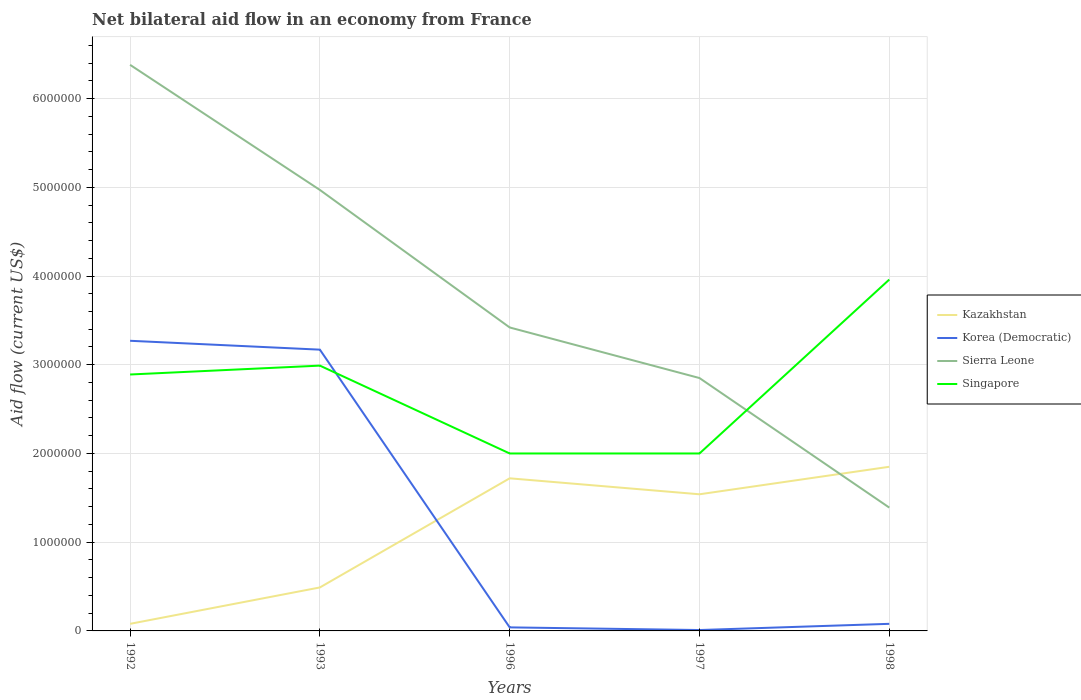Does the line corresponding to Sierra Leone intersect with the line corresponding to Korea (Democratic)?
Ensure brevity in your answer.  No. Is the number of lines equal to the number of legend labels?
Make the answer very short. Yes. In which year was the net bilateral aid flow in Korea (Democratic) maximum?
Your response must be concise. 1997. What is the total net bilateral aid flow in Sierra Leone in the graph?
Provide a short and direct response. 1.55e+06. What is the difference between the highest and the second highest net bilateral aid flow in Korea (Democratic)?
Make the answer very short. 3.26e+06. Is the net bilateral aid flow in Kazakhstan strictly greater than the net bilateral aid flow in Singapore over the years?
Make the answer very short. Yes. What is the difference between two consecutive major ticks on the Y-axis?
Provide a succinct answer. 1.00e+06. Are the values on the major ticks of Y-axis written in scientific E-notation?
Give a very brief answer. No. Does the graph contain grids?
Make the answer very short. Yes. How many legend labels are there?
Offer a very short reply. 4. What is the title of the graph?
Offer a terse response. Net bilateral aid flow in an economy from France. What is the label or title of the X-axis?
Your response must be concise. Years. What is the label or title of the Y-axis?
Your response must be concise. Aid flow (current US$). What is the Aid flow (current US$) of Korea (Democratic) in 1992?
Your answer should be very brief. 3.27e+06. What is the Aid flow (current US$) of Sierra Leone in 1992?
Provide a succinct answer. 6.38e+06. What is the Aid flow (current US$) in Singapore in 1992?
Your answer should be very brief. 2.89e+06. What is the Aid flow (current US$) in Korea (Democratic) in 1993?
Provide a short and direct response. 3.17e+06. What is the Aid flow (current US$) of Sierra Leone in 1993?
Provide a succinct answer. 4.97e+06. What is the Aid flow (current US$) in Singapore in 1993?
Your answer should be very brief. 2.99e+06. What is the Aid flow (current US$) of Kazakhstan in 1996?
Keep it short and to the point. 1.72e+06. What is the Aid flow (current US$) in Sierra Leone in 1996?
Keep it short and to the point. 3.42e+06. What is the Aid flow (current US$) of Singapore in 1996?
Ensure brevity in your answer.  2.00e+06. What is the Aid flow (current US$) of Kazakhstan in 1997?
Your answer should be compact. 1.54e+06. What is the Aid flow (current US$) in Korea (Democratic) in 1997?
Your answer should be compact. 10000. What is the Aid flow (current US$) of Sierra Leone in 1997?
Your response must be concise. 2.85e+06. What is the Aid flow (current US$) in Singapore in 1997?
Offer a very short reply. 2.00e+06. What is the Aid flow (current US$) in Kazakhstan in 1998?
Your response must be concise. 1.85e+06. What is the Aid flow (current US$) in Korea (Democratic) in 1998?
Your answer should be very brief. 8.00e+04. What is the Aid flow (current US$) of Sierra Leone in 1998?
Your answer should be very brief. 1.39e+06. What is the Aid flow (current US$) of Singapore in 1998?
Ensure brevity in your answer.  3.96e+06. Across all years, what is the maximum Aid flow (current US$) in Kazakhstan?
Provide a short and direct response. 1.85e+06. Across all years, what is the maximum Aid flow (current US$) of Korea (Democratic)?
Your answer should be compact. 3.27e+06. Across all years, what is the maximum Aid flow (current US$) of Sierra Leone?
Your answer should be compact. 6.38e+06. Across all years, what is the maximum Aid flow (current US$) of Singapore?
Keep it short and to the point. 3.96e+06. Across all years, what is the minimum Aid flow (current US$) of Sierra Leone?
Provide a succinct answer. 1.39e+06. What is the total Aid flow (current US$) of Kazakhstan in the graph?
Your answer should be very brief. 5.68e+06. What is the total Aid flow (current US$) of Korea (Democratic) in the graph?
Ensure brevity in your answer.  6.57e+06. What is the total Aid flow (current US$) of Sierra Leone in the graph?
Offer a terse response. 1.90e+07. What is the total Aid flow (current US$) of Singapore in the graph?
Offer a very short reply. 1.38e+07. What is the difference between the Aid flow (current US$) in Kazakhstan in 1992 and that in 1993?
Keep it short and to the point. -4.10e+05. What is the difference between the Aid flow (current US$) of Sierra Leone in 1992 and that in 1993?
Your response must be concise. 1.41e+06. What is the difference between the Aid flow (current US$) in Kazakhstan in 1992 and that in 1996?
Your response must be concise. -1.64e+06. What is the difference between the Aid flow (current US$) of Korea (Democratic) in 1992 and that in 1996?
Offer a terse response. 3.23e+06. What is the difference between the Aid flow (current US$) in Sierra Leone in 1992 and that in 1996?
Your answer should be compact. 2.96e+06. What is the difference between the Aid flow (current US$) in Singapore in 1992 and that in 1996?
Keep it short and to the point. 8.90e+05. What is the difference between the Aid flow (current US$) in Kazakhstan in 1992 and that in 1997?
Offer a terse response. -1.46e+06. What is the difference between the Aid flow (current US$) of Korea (Democratic) in 1992 and that in 1997?
Offer a very short reply. 3.26e+06. What is the difference between the Aid flow (current US$) in Sierra Leone in 1992 and that in 1997?
Keep it short and to the point. 3.53e+06. What is the difference between the Aid flow (current US$) in Singapore in 1992 and that in 1997?
Offer a terse response. 8.90e+05. What is the difference between the Aid flow (current US$) of Kazakhstan in 1992 and that in 1998?
Give a very brief answer. -1.77e+06. What is the difference between the Aid flow (current US$) of Korea (Democratic) in 1992 and that in 1998?
Your response must be concise. 3.19e+06. What is the difference between the Aid flow (current US$) of Sierra Leone in 1992 and that in 1998?
Give a very brief answer. 4.99e+06. What is the difference between the Aid flow (current US$) of Singapore in 1992 and that in 1998?
Your answer should be very brief. -1.07e+06. What is the difference between the Aid flow (current US$) of Kazakhstan in 1993 and that in 1996?
Provide a succinct answer. -1.23e+06. What is the difference between the Aid flow (current US$) in Korea (Democratic) in 1993 and that in 1996?
Provide a short and direct response. 3.13e+06. What is the difference between the Aid flow (current US$) of Sierra Leone in 1993 and that in 1996?
Your answer should be very brief. 1.55e+06. What is the difference between the Aid flow (current US$) of Singapore in 1993 and that in 1996?
Provide a succinct answer. 9.90e+05. What is the difference between the Aid flow (current US$) in Kazakhstan in 1993 and that in 1997?
Your response must be concise. -1.05e+06. What is the difference between the Aid flow (current US$) of Korea (Democratic) in 1993 and that in 1997?
Provide a succinct answer. 3.16e+06. What is the difference between the Aid flow (current US$) of Sierra Leone in 1993 and that in 1997?
Provide a succinct answer. 2.12e+06. What is the difference between the Aid flow (current US$) of Singapore in 1993 and that in 1997?
Provide a succinct answer. 9.90e+05. What is the difference between the Aid flow (current US$) of Kazakhstan in 1993 and that in 1998?
Provide a short and direct response. -1.36e+06. What is the difference between the Aid flow (current US$) in Korea (Democratic) in 1993 and that in 1998?
Ensure brevity in your answer.  3.09e+06. What is the difference between the Aid flow (current US$) of Sierra Leone in 1993 and that in 1998?
Keep it short and to the point. 3.58e+06. What is the difference between the Aid flow (current US$) of Singapore in 1993 and that in 1998?
Offer a very short reply. -9.70e+05. What is the difference between the Aid flow (current US$) in Korea (Democratic) in 1996 and that in 1997?
Give a very brief answer. 3.00e+04. What is the difference between the Aid flow (current US$) in Sierra Leone in 1996 and that in 1997?
Keep it short and to the point. 5.70e+05. What is the difference between the Aid flow (current US$) in Singapore in 1996 and that in 1997?
Provide a short and direct response. 0. What is the difference between the Aid flow (current US$) in Kazakhstan in 1996 and that in 1998?
Provide a succinct answer. -1.30e+05. What is the difference between the Aid flow (current US$) of Korea (Democratic) in 1996 and that in 1998?
Keep it short and to the point. -4.00e+04. What is the difference between the Aid flow (current US$) in Sierra Leone in 1996 and that in 1998?
Provide a succinct answer. 2.03e+06. What is the difference between the Aid flow (current US$) in Singapore in 1996 and that in 1998?
Your answer should be very brief. -1.96e+06. What is the difference between the Aid flow (current US$) in Kazakhstan in 1997 and that in 1998?
Provide a succinct answer. -3.10e+05. What is the difference between the Aid flow (current US$) in Sierra Leone in 1997 and that in 1998?
Your response must be concise. 1.46e+06. What is the difference between the Aid flow (current US$) of Singapore in 1997 and that in 1998?
Provide a succinct answer. -1.96e+06. What is the difference between the Aid flow (current US$) in Kazakhstan in 1992 and the Aid flow (current US$) in Korea (Democratic) in 1993?
Keep it short and to the point. -3.09e+06. What is the difference between the Aid flow (current US$) of Kazakhstan in 1992 and the Aid flow (current US$) of Sierra Leone in 1993?
Offer a terse response. -4.89e+06. What is the difference between the Aid flow (current US$) in Kazakhstan in 1992 and the Aid flow (current US$) in Singapore in 1993?
Offer a terse response. -2.91e+06. What is the difference between the Aid flow (current US$) of Korea (Democratic) in 1992 and the Aid flow (current US$) of Sierra Leone in 1993?
Offer a terse response. -1.70e+06. What is the difference between the Aid flow (current US$) of Sierra Leone in 1992 and the Aid flow (current US$) of Singapore in 1993?
Give a very brief answer. 3.39e+06. What is the difference between the Aid flow (current US$) of Kazakhstan in 1992 and the Aid flow (current US$) of Sierra Leone in 1996?
Offer a terse response. -3.34e+06. What is the difference between the Aid flow (current US$) of Kazakhstan in 1992 and the Aid flow (current US$) of Singapore in 1996?
Offer a very short reply. -1.92e+06. What is the difference between the Aid flow (current US$) in Korea (Democratic) in 1992 and the Aid flow (current US$) in Singapore in 1996?
Provide a short and direct response. 1.27e+06. What is the difference between the Aid flow (current US$) of Sierra Leone in 1992 and the Aid flow (current US$) of Singapore in 1996?
Your answer should be compact. 4.38e+06. What is the difference between the Aid flow (current US$) in Kazakhstan in 1992 and the Aid flow (current US$) in Sierra Leone in 1997?
Keep it short and to the point. -2.77e+06. What is the difference between the Aid flow (current US$) in Kazakhstan in 1992 and the Aid flow (current US$) in Singapore in 1997?
Your answer should be compact. -1.92e+06. What is the difference between the Aid flow (current US$) in Korea (Democratic) in 1992 and the Aid flow (current US$) in Sierra Leone in 1997?
Give a very brief answer. 4.20e+05. What is the difference between the Aid flow (current US$) of Korea (Democratic) in 1992 and the Aid flow (current US$) of Singapore in 1997?
Provide a short and direct response. 1.27e+06. What is the difference between the Aid flow (current US$) of Sierra Leone in 1992 and the Aid flow (current US$) of Singapore in 1997?
Provide a short and direct response. 4.38e+06. What is the difference between the Aid flow (current US$) of Kazakhstan in 1992 and the Aid flow (current US$) of Korea (Democratic) in 1998?
Keep it short and to the point. 0. What is the difference between the Aid flow (current US$) in Kazakhstan in 1992 and the Aid flow (current US$) in Sierra Leone in 1998?
Offer a very short reply. -1.31e+06. What is the difference between the Aid flow (current US$) in Kazakhstan in 1992 and the Aid flow (current US$) in Singapore in 1998?
Your answer should be very brief. -3.88e+06. What is the difference between the Aid flow (current US$) of Korea (Democratic) in 1992 and the Aid flow (current US$) of Sierra Leone in 1998?
Your answer should be compact. 1.88e+06. What is the difference between the Aid flow (current US$) in Korea (Democratic) in 1992 and the Aid flow (current US$) in Singapore in 1998?
Provide a succinct answer. -6.90e+05. What is the difference between the Aid flow (current US$) of Sierra Leone in 1992 and the Aid flow (current US$) of Singapore in 1998?
Give a very brief answer. 2.42e+06. What is the difference between the Aid flow (current US$) in Kazakhstan in 1993 and the Aid flow (current US$) in Korea (Democratic) in 1996?
Give a very brief answer. 4.50e+05. What is the difference between the Aid flow (current US$) in Kazakhstan in 1993 and the Aid flow (current US$) in Sierra Leone in 1996?
Offer a very short reply. -2.93e+06. What is the difference between the Aid flow (current US$) in Kazakhstan in 1993 and the Aid flow (current US$) in Singapore in 1996?
Your response must be concise. -1.51e+06. What is the difference between the Aid flow (current US$) of Korea (Democratic) in 1993 and the Aid flow (current US$) of Singapore in 1996?
Your answer should be compact. 1.17e+06. What is the difference between the Aid flow (current US$) in Sierra Leone in 1993 and the Aid flow (current US$) in Singapore in 1996?
Give a very brief answer. 2.97e+06. What is the difference between the Aid flow (current US$) of Kazakhstan in 1993 and the Aid flow (current US$) of Sierra Leone in 1997?
Ensure brevity in your answer.  -2.36e+06. What is the difference between the Aid flow (current US$) in Kazakhstan in 1993 and the Aid flow (current US$) in Singapore in 1997?
Provide a succinct answer. -1.51e+06. What is the difference between the Aid flow (current US$) in Korea (Democratic) in 1993 and the Aid flow (current US$) in Singapore in 1997?
Your answer should be compact. 1.17e+06. What is the difference between the Aid flow (current US$) of Sierra Leone in 1993 and the Aid flow (current US$) of Singapore in 1997?
Keep it short and to the point. 2.97e+06. What is the difference between the Aid flow (current US$) of Kazakhstan in 1993 and the Aid flow (current US$) of Korea (Democratic) in 1998?
Provide a short and direct response. 4.10e+05. What is the difference between the Aid flow (current US$) in Kazakhstan in 1993 and the Aid flow (current US$) in Sierra Leone in 1998?
Your response must be concise. -9.00e+05. What is the difference between the Aid flow (current US$) of Kazakhstan in 1993 and the Aid flow (current US$) of Singapore in 1998?
Your response must be concise. -3.47e+06. What is the difference between the Aid flow (current US$) of Korea (Democratic) in 1993 and the Aid flow (current US$) of Sierra Leone in 1998?
Your response must be concise. 1.78e+06. What is the difference between the Aid flow (current US$) in Korea (Democratic) in 1993 and the Aid flow (current US$) in Singapore in 1998?
Your answer should be compact. -7.90e+05. What is the difference between the Aid flow (current US$) of Sierra Leone in 1993 and the Aid flow (current US$) of Singapore in 1998?
Provide a short and direct response. 1.01e+06. What is the difference between the Aid flow (current US$) in Kazakhstan in 1996 and the Aid flow (current US$) in Korea (Democratic) in 1997?
Provide a succinct answer. 1.71e+06. What is the difference between the Aid flow (current US$) of Kazakhstan in 1996 and the Aid flow (current US$) of Sierra Leone in 1997?
Provide a short and direct response. -1.13e+06. What is the difference between the Aid flow (current US$) of Kazakhstan in 1996 and the Aid flow (current US$) of Singapore in 1997?
Give a very brief answer. -2.80e+05. What is the difference between the Aid flow (current US$) of Korea (Democratic) in 1996 and the Aid flow (current US$) of Sierra Leone in 1997?
Keep it short and to the point. -2.81e+06. What is the difference between the Aid flow (current US$) in Korea (Democratic) in 1996 and the Aid flow (current US$) in Singapore in 1997?
Your answer should be compact. -1.96e+06. What is the difference between the Aid flow (current US$) of Sierra Leone in 1996 and the Aid flow (current US$) of Singapore in 1997?
Provide a succinct answer. 1.42e+06. What is the difference between the Aid flow (current US$) of Kazakhstan in 1996 and the Aid flow (current US$) of Korea (Democratic) in 1998?
Make the answer very short. 1.64e+06. What is the difference between the Aid flow (current US$) in Kazakhstan in 1996 and the Aid flow (current US$) in Sierra Leone in 1998?
Provide a succinct answer. 3.30e+05. What is the difference between the Aid flow (current US$) of Kazakhstan in 1996 and the Aid flow (current US$) of Singapore in 1998?
Provide a succinct answer. -2.24e+06. What is the difference between the Aid flow (current US$) in Korea (Democratic) in 1996 and the Aid flow (current US$) in Sierra Leone in 1998?
Offer a very short reply. -1.35e+06. What is the difference between the Aid flow (current US$) of Korea (Democratic) in 1996 and the Aid flow (current US$) of Singapore in 1998?
Provide a short and direct response. -3.92e+06. What is the difference between the Aid flow (current US$) in Sierra Leone in 1996 and the Aid flow (current US$) in Singapore in 1998?
Your answer should be compact. -5.40e+05. What is the difference between the Aid flow (current US$) of Kazakhstan in 1997 and the Aid flow (current US$) of Korea (Democratic) in 1998?
Make the answer very short. 1.46e+06. What is the difference between the Aid flow (current US$) in Kazakhstan in 1997 and the Aid flow (current US$) in Sierra Leone in 1998?
Make the answer very short. 1.50e+05. What is the difference between the Aid flow (current US$) in Kazakhstan in 1997 and the Aid flow (current US$) in Singapore in 1998?
Offer a very short reply. -2.42e+06. What is the difference between the Aid flow (current US$) of Korea (Democratic) in 1997 and the Aid flow (current US$) of Sierra Leone in 1998?
Make the answer very short. -1.38e+06. What is the difference between the Aid flow (current US$) of Korea (Democratic) in 1997 and the Aid flow (current US$) of Singapore in 1998?
Provide a succinct answer. -3.95e+06. What is the difference between the Aid flow (current US$) of Sierra Leone in 1997 and the Aid flow (current US$) of Singapore in 1998?
Ensure brevity in your answer.  -1.11e+06. What is the average Aid flow (current US$) in Kazakhstan per year?
Give a very brief answer. 1.14e+06. What is the average Aid flow (current US$) in Korea (Democratic) per year?
Offer a very short reply. 1.31e+06. What is the average Aid flow (current US$) in Sierra Leone per year?
Provide a succinct answer. 3.80e+06. What is the average Aid flow (current US$) in Singapore per year?
Your answer should be very brief. 2.77e+06. In the year 1992, what is the difference between the Aid flow (current US$) in Kazakhstan and Aid flow (current US$) in Korea (Democratic)?
Make the answer very short. -3.19e+06. In the year 1992, what is the difference between the Aid flow (current US$) in Kazakhstan and Aid flow (current US$) in Sierra Leone?
Give a very brief answer. -6.30e+06. In the year 1992, what is the difference between the Aid flow (current US$) of Kazakhstan and Aid flow (current US$) of Singapore?
Provide a succinct answer. -2.81e+06. In the year 1992, what is the difference between the Aid flow (current US$) of Korea (Democratic) and Aid flow (current US$) of Sierra Leone?
Offer a very short reply. -3.11e+06. In the year 1992, what is the difference between the Aid flow (current US$) in Sierra Leone and Aid flow (current US$) in Singapore?
Your answer should be compact. 3.49e+06. In the year 1993, what is the difference between the Aid flow (current US$) in Kazakhstan and Aid flow (current US$) in Korea (Democratic)?
Provide a succinct answer. -2.68e+06. In the year 1993, what is the difference between the Aid flow (current US$) in Kazakhstan and Aid flow (current US$) in Sierra Leone?
Ensure brevity in your answer.  -4.48e+06. In the year 1993, what is the difference between the Aid flow (current US$) of Kazakhstan and Aid flow (current US$) of Singapore?
Provide a short and direct response. -2.50e+06. In the year 1993, what is the difference between the Aid flow (current US$) in Korea (Democratic) and Aid flow (current US$) in Sierra Leone?
Your answer should be compact. -1.80e+06. In the year 1993, what is the difference between the Aid flow (current US$) of Korea (Democratic) and Aid flow (current US$) of Singapore?
Ensure brevity in your answer.  1.80e+05. In the year 1993, what is the difference between the Aid flow (current US$) of Sierra Leone and Aid flow (current US$) of Singapore?
Provide a succinct answer. 1.98e+06. In the year 1996, what is the difference between the Aid flow (current US$) of Kazakhstan and Aid flow (current US$) of Korea (Democratic)?
Your answer should be very brief. 1.68e+06. In the year 1996, what is the difference between the Aid flow (current US$) in Kazakhstan and Aid flow (current US$) in Sierra Leone?
Provide a short and direct response. -1.70e+06. In the year 1996, what is the difference between the Aid flow (current US$) in Kazakhstan and Aid flow (current US$) in Singapore?
Make the answer very short. -2.80e+05. In the year 1996, what is the difference between the Aid flow (current US$) of Korea (Democratic) and Aid flow (current US$) of Sierra Leone?
Keep it short and to the point. -3.38e+06. In the year 1996, what is the difference between the Aid flow (current US$) of Korea (Democratic) and Aid flow (current US$) of Singapore?
Give a very brief answer. -1.96e+06. In the year 1996, what is the difference between the Aid flow (current US$) of Sierra Leone and Aid flow (current US$) of Singapore?
Provide a short and direct response. 1.42e+06. In the year 1997, what is the difference between the Aid flow (current US$) of Kazakhstan and Aid flow (current US$) of Korea (Democratic)?
Make the answer very short. 1.53e+06. In the year 1997, what is the difference between the Aid flow (current US$) in Kazakhstan and Aid flow (current US$) in Sierra Leone?
Your answer should be compact. -1.31e+06. In the year 1997, what is the difference between the Aid flow (current US$) in Kazakhstan and Aid flow (current US$) in Singapore?
Make the answer very short. -4.60e+05. In the year 1997, what is the difference between the Aid flow (current US$) in Korea (Democratic) and Aid flow (current US$) in Sierra Leone?
Provide a short and direct response. -2.84e+06. In the year 1997, what is the difference between the Aid flow (current US$) in Korea (Democratic) and Aid flow (current US$) in Singapore?
Make the answer very short. -1.99e+06. In the year 1997, what is the difference between the Aid flow (current US$) of Sierra Leone and Aid flow (current US$) of Singapore?
Offer a terse response. 8.50e+05. In the year 1998, what is the difference between the Aid flow (current US$) in Kazakhstan and Aid flow (current US$) in Korea (Democratic)?
Keep it short and to the point. 1.77e+06. In the year 1998, what is the difference between the Aid flow (current US$) of Kazakhstan and Aid flow (current US$) of Sierra Leone?
Give a very brief answer. 4.60e+05. In the year 1998, what is the difference between the Aid flow (current US$) of Kazakhstan and Aid flow (current US$) of Singapore?
Give a very brief answer. -2.11e+06. In the year 1998, what is the difference between the Aid flow (current US$) in Korea (Democratic) and Aid flow (current US$) in Sierra Leone?
Your answer should be compact. -1.31e+06. In the year 1998, what is the difference between the Aid flow (current US$) of Korea (Democratic) and Aid flow (current US$) of Singapore?
Your response must be concise. -3.88e+06. In the year 1998, what is the difference between the Aid flow (current US$) of Sierra Leone and Aid flow (current US$) of Singapore?
Make the answer very short. -2.57e+06. What is the ratio of the Aid flow (current US$) of Kazakhstan in 1992 to that in 1993?
Your answer should be very brief. 0.16. What is the ratio of the Aid flow (current US$) of Korea (Democratic) in 1992 to that in 1993?
Offer a terse response. 1.03. What is the ratio of the Aid flow (current US$) of Sierra Leone in 1992 to that in 1993?
Your answer should be compact. 1.28. What is the ratio of the Aid flow (current US$) in Singapore in 1992 to that in 1993?
Offer a terse response. 0.97. What is the ratio of the Aid flow (current US$) of Kazakhstan in 1992 to that in 1996?
Your answer should be compact. 0.05. What is the ratio of the Aid flow (current US$) in Korea (Democratic) in 1992 to that in 1996?
Keep it short and to the point. 81.75. What is the ratio of the Aid flow (current US$) of Sierra Leone in 1992 to that in 1996?
Make the answer very short. 1.87. What is the ratio of the Aid flow (current US$) of Singapore in 1992 to that in 1996?
Offer a very short reply. 1.45. What is the ratio of the Aid flow (current US$) in Kazakhstan in 1992 to that in 1997?
Provide a succinct answer. 0.05. What is the ratio of the Aid flow (current US$) of Korea (Democratic) in 1992 to that in 1997?
Your answer should be compact. 327. What is the ratio of the Aid flow (current US$) in Sierra Leone in 1992 to that in 1997?
Your answer should be very brief. 2.24. What is the ratio of the Aid flow (current US$) in Singapore in 1992 to that in 1997?
Offer a very short reply. 1.45. What is the ratio of the Aid flow (current US$) in Kazakhstan in 1992 to that in 1998?
Provide a succinct answer. 0.04. What is the ratio of the Aid flow (current US$) in Korea (Democratic) in 1992 to that in 1998?
Offer a very short reply. 40.88. What is the ratio of the Aid flow (current US$) in Sierra Leone in 1992 to that in 1998?
Keep it short and to the point. 4.59. What is the ratio of the Aid flow (current US$) of Singapore in 1992 to that in 1998?
Your answer should be very brief. 0.73. What is the ratio of the Aid flow (current US$) in Kazakhstan in 1993 to that in 1996?
Offer a very short reply. 0.28. What is the ratio of the Aid flow (current US$) of Korea (Democratic) in 1993 to that in 1996?
Offer a terse response. 79.25. What is the ratio of the Aid flow (current US$) of Sierra Leone in 1993 to that in 1996?
Keep it short and to the point. 1.45. What is the ratio of the Aid flow (current US$) in Singapore in 1993 to that in 1996?
Give a very brief answer. 1.5. What is the ratio of the Aid flow (current US$) of Kazakhstan in 1993 to that in 1997?
Make the answer very short. 0.32. What is the ratio of the Aid flow (current US$) in Korea (Democratic) in 1993 to that in 1997?
Make the answer very short. 317. What is the ratio of the Aid flow (current US$) in Sierra Leone in 1993 to that in 1997?
Your answer should be very brief. 1.74. What is the ratio of the Aid flow (current US$) of Singapore in 1993 to that in 1997?
Offer a very short reply. 1.5. What is the ratio of the Aid flow (current US$) of Kazakhstan in 1993 to that in 1998?
Ensure brevity in your answer.  0.26. What is the ratio of the Aid flow (current US$) in Korea (Democratic) in 1993 to that in 1998?
Make the answer very short. 39.62. What is the ratio of the Aid flow (current US$) in Sierra Leone in 1993 to that in 1998?
Give a very brief answer. 3.58. What is the ratio of the Aid flow (current US$) in Singapore in 1993 to that in 1998?
Your answer should be very brief. 0.76. What is the ratio of the Aid flow (current US$) of Kazakhstan in 1996 to that in 1997?
Provide a succinct answer. 1.12. What is the ratio of the Aid flow (current US$) in Singapore in 1996 to that in 1997?
Offer a terse response. 1. What is the ratio of the Aid flow (current US$) of Kazakhstan in 1996 to that in 1998?
Your answer should be very brief. 0.93. What is the ratio of the Aid flow (current US$) in Sierra Leone in 1996 to that in 1998?
Give a very brief answer. 2.46. What is the ratio of the Aid flow (current US$) of Singapore in 1996 to that in 1998?
Your answer should be very brief. 0.51. What is the ratio of the Aid flow (current US$) of Kazakhstan in 1997 to that in 1998?
Keep it short and to the point. 0.83. What is the ratio of the Aid flow (current US$) of Korea (Democratic) in 1997 to that in 1998?
Your answer should be compact. 0.12. What is the ratio of the Aid flow (current US$) of Sierra Leone in 1997 to that in 1998?
Ensure brevity in your answer.  2.05. What is the ratio of the Aid flow (current US$) of Singapore in 1997 to that in 1998?
Ensure brevity in your answer.  0.51. What is the difference between the highest and the second highest Aid flow (current US$) of Kazakhstan?
Your response must be concise. 1.30e+05. What is the difference between the highest and the second highest Aid flow (current US$) of Korea (Democratic)?
Provide a short and direct response. 1.00e+05. What is the difference between the highest and the second highest Aid flow (current US$) of Sierra Leone?
Your answer should be compact. 1.41e+06. What is the difference between the highest and the second highest Aid flow (current US$) in Singapore?
Make the answer very short. 9.70e+05. What is the difference between the highest and the lowest Aid flow (current US$) of Kazakhstan?
Provide a short and direct response. 1.77e+06. What is the difference between the highest and the lowest Aid flow (current US$) of Korea (Democratic)?
Offer a terse response. 3.26e+06. What is the difference between the highest and the lowest Aid flow (current US$) of Sierra Leone?
Keep it short and to the point. 4.99e+06. What is the difference between the highest and the lowest Aid flow (current US$) in Singapore?
Your response must be concise. 1.96e+06. 